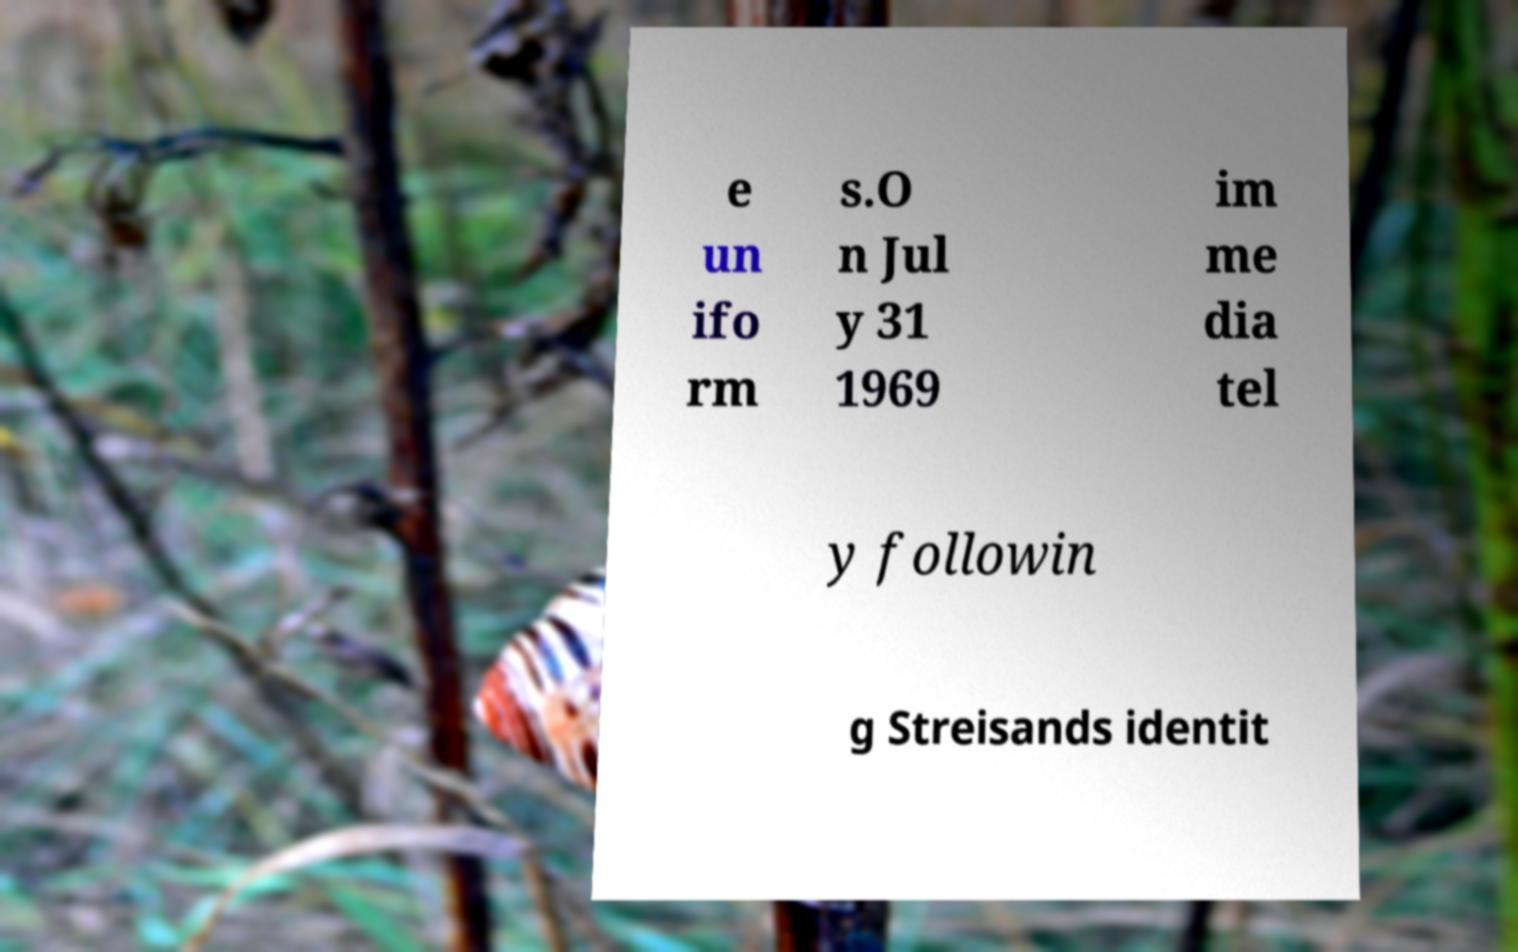Could you extract and type out the text from this image? e un ifo rm s.O n Jul y 31 1969 im me dia tel y followin g Streisands identit 